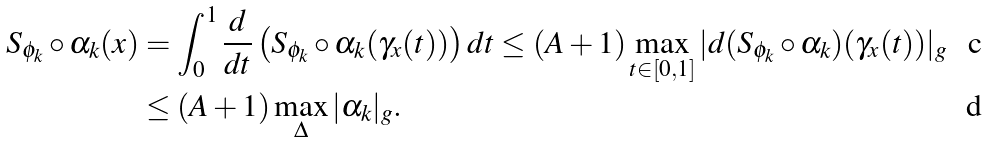<formula> <loc_0><loc_0><loc_500><loc_500>S _ { \phi _ { k } } \circ \alpha _ { k } ( x ) & = \int _ { 0 } ^ { 1 } \frac { d } { d t } \left ( S _ { \phi _ { k } } \circ \alpha _ { k } ( \gamma _ { x } ( t ) ) \right ) d t \leq ( A + 1 ) \max _ { t \in [ 0 , 1 ] } | d ( S _ { \phi _ { k } } \circ \alpha _ { k } ) ( \gamma _ { x } ( t ) ) | _ { g } \\ & \leq ( A + 1 ) \max _ { \Delta } | \alpha _ { k } | _ { g } .</formula> 